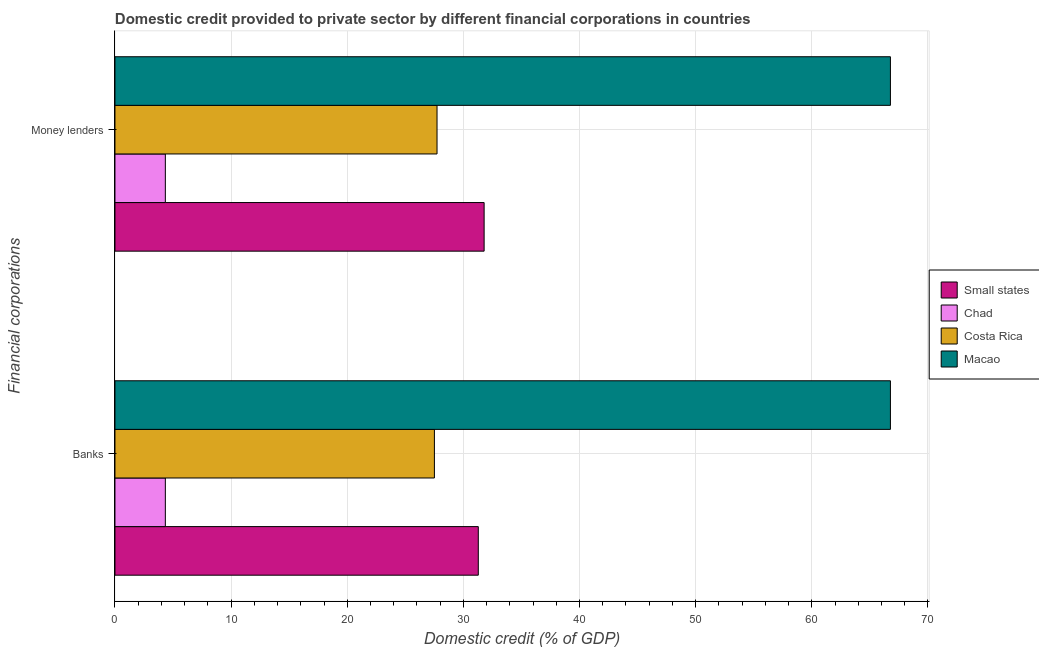How many different coloured bars are there?
Keep it short and to the point. 4. How many groups of bars are there?
Keep it short and to the point. 2. Are the number of bars on each tick of the Y-axis equal?
Ensure brevity in your answer.  Yes. What is the label of the 1st group of bars from the top?
Your response must be concise. Money lenders. What is the domestic credit provided by banks in Small states?
Your answer should be very brief. 31.28. Across all countries, what is the maximum domestic credit provided by money lenders?
Ensure brevity in your answer.  66.77. Across all countries, what is the minimum domestic credit provided by money lenders?
Your response must be concise. 4.34. In which country was the domestic credit provided by banks maximum?
Your response must be concise. Macao. In which country was the domestic credit provided by money lenders minimum?
Make the answer very short. Chad. What is the total domestic credit provided by banks in the graph?
Provide a succinct answer. 129.9. What is the difference between the domestic credit provided by money lenders in Chad and that in Costa Rica?
Offer a very short reply. -23.39. What is the difference between the domestic credit provided by banks in Costa Rica and the domestic credit provided by money lenders in Small states?
Give a very brief answer. -4.28. What is the average domestic credit provided by banks per country?
Provide a succinct answer. 32.48. What is the difference between the domestic credit provided by money lenders and domestic credit provided by banks in Small states?
Provide a short and direct response. 0.5. What is the ratio of the domestic credit provided by money lenders in Macao to that in Small states?
Give a very brief answer. 2.1. In how many countries, is the domestic credit provided by banks greater than the average domestic credit provided by banks taken over all countries?
Offer a very short reply. 1. What does the 4th bar from the top in Banks represents?
Offer a terse response. Small states. What does the 2nd bar from the bottom in Money lenders represents?
Offer a very short reply. Chad. How many countries are there in the graph?
Ensure brevity in your answer.  4. What is the difference between two consecutive major ticks on the X-axis?
Provide a succinct answer. 10. Does the graph contain any zero values?
Provide a succinct answer. No. Does the graph contain grids?
Make the answer very short. Yes. What is the title of the graph?
Your answer should be compact. Domestic credit provided to private sector by different financial corporations in countries. Does "Marshall Islands" appear as one of the legend labels in the graph?
Provide a succinct answer. No. What is the label or title of the X-axis?
Keep it short and to the point. Domestic credit (% of GDP). What is the label or title of the Y-axis?
Ensure brevity in your answer.  Financial corporations. What is the Domestic credit (% of GDP) in Small states in Banks?
Give a very brief answer. 31.28. What is the Domestic credit (% of GDP) in Chad in Banks?
Offer a terse response. 4.34. What is the Domestic credit (% of GDP) in Costa Rica in Banks?
Your answer should be very brief. 27.51. What is the Domestic credit (% of GDP) in Macao in Banks?
Ensure brevity in your answer.  66.77. What is the Domestic credit (% of GDP) of Small states in Money lenders?
Your answer should be very brief. 31.79. What is the Domestic credit (% of GDP) in Chad in Money lenders?
Keep it short and to the point. 4.34. What is the Domestic credit (% of GDP) of Costa Rica in Money lenders?
Provide a short and direct response. 27.73. What is the Domestic credit (% of GDP) of Macao in Money lenders?
Give a very brief answer. 66.77. Across all Financial corporations, what is the maximum Domestic credit (% of GDP) in Small states?
Offer a very short reply. 31.79. Across all Financial corporations, what is the maximum Domestic credit (% of GDP) of Chad?
Your answer should be very brief. 4.34. Across all Financial corporations, what is the maximum Domestic credit (% of GDP) of Costa Rica?
Ensure brevity in your answer.  27.73. Across all Financial corporations, what is the maximum Domestic credit (% of GDP) of Macao?
Keep it short and to the point. 66.77. Across all Financial corporations, what is the minimum Domestic credit (% of GDP) in Small states?
Your response must be concise. 31.28. Across all Financial corporations, what is the minimum Domestic credit (% of GDP) in Chad?
Provide a short and direct response. 4.34. Across all Financial corporations, what is the minimum Domestic credit (% of GDP) in Costa Rica?
Offer a very short reply. 27.51. Across all Financial corporations, what is the minimum Domestic credit (% of GDP) of Macao?
Your answer should be compact. 66.77. What is the total Domestic credit (% of GDP) of Small states in the graph?
Provide a short and direct response. 63.07. What is the total Domestic credit (% of GDP) in Chad in the graph?
Your answer should be very brief. 8.68. What is the total Domestic credit (% of GDP) of Costa Rica in the graph?
Provide a short and direct response. 55.24. What is the total Domestic credit (% of GDP) of Macao in the graph?
Keep it short and to the point. 133.54. What is the difference between the Domestic credit (% of GDP) in Small states in Banks and that in Money lenders?
Your answer should be very brief. -0.5. What is the difference between the Domestic credit (% of GDP) of Chad in Banks and that in Money lenders?
Provide a short and direct response. 0. What is the difference between the Domestic credit (% of GDP) in Costa Rica in Banks and that in Money lenders?
Make the answer very short. -0.23. What is the difference between the Domestic credit (% of GDP) in Small states in Banks and the Domestic credit (% of GDP) in Chad in Money lenders?
Offer a terse response. 26.95. What is the difference between the Domestic credit (% of GDP) in Small states in Banks and the Domestic credit (% of GDP) in Costa Rica in Money lenders?
Your answer should be compact. 3.55. What is the difference between the Domestic credit (% of GDP) of Small states in Banks and the Domestic credit (% of GDP) of Macao in Money lenders?
Provide a short and direct response. -35.49. What is the difference between the Domestic credit (% of GDP) of Chad in Banks and the Domestic credit (% of GDP) of Costa Rica in Money lenders?
Your answer should be very brief. -23.39. What is the difference between the Domestic credit (% of GDP) of Chad in Banks and the Domestic credit (% of GDP) of Macao in Money lenders?
Keep it short and to the point. -62.43. What is the difference between the Domestic credit (% of GDP) of Costa Rica in Banks and the Domestic credit (% of GDP) of Macao in Money lenders?
Provide a succinct answer. -39.27. What is the average Domestic credit (% of GDP) in Small states per Financial corporations?
Make the answer very short. 31.54. What is the average Domestic credit (% of GDP) of Chad per Financial corporations?
Offer a terse response. 4.34. What is the average Domestic credit (% of GDP) of Costa Rica per Financial corporations?
Provide a short and direct response. 27.62. What is the average Domestic credit (% of GDP) in Macao per Financial corporations?
Give a very brief answer. 66.77. What is the difference between the Domestic credit (% of GDP) of Small states and Domestic credit (% of GDP) of Chad in Banks?
Make the answer very short. 26.95. What is the difference between the Domestic credit (% of GDP) in Small states and Domestic credit (% of GDP) in Costa Rica in Banks?
Keep it short and to the point. 3.78. What is the difference between the Domestic credit (% of GDP) of Small states and Domestic credit (% of GDP) of Macao in Banks?
Give a very brief answer. -35.49. What is the difference between the Domestic credit (% of GDP) in Chad and Domestic credit (% of GDP) in Costa Rica in Banks?
Give a very brief answer. -23.17. What is the difference between the Domestic credit (% of GDP) of Chad and Domestic credit (% of GDP) of Macao in Banks?
Make the answer very short. -62.43. What is the difference between the Domestic credit (% of GDP) of Costa Rica and Domestic credit (% of GDP) of Macao in Banks?
Give a very brief answer. -39.27. What is the difference between the Domestic credit (% of GDP) in Small states and Domestic credit (% of GDP) in Chad in Money lenders?
Your answer should be very brief. 27.45. What is the difference between the Domestic credit (% of GDP) of Small states and Domestic credit (% of GDP) of Costa Rica in Money lenders?
Your answer should be very brief. 4.06. What is the difference between the Domestic credit (% of GDP) of Small states and Domestic credit (% of GDP) of Macao in Money lenders?
Offer a very short reply. -34.98. What is the difference between the Domestic credit (% of GDP) of Chad and Domestic credit (% of GDP) of Costa Rica in Money lenders?
Provide a succinct answer. -23.39. What is the difference between the Domestic credit (% of GDP) in Chad and Domestic credit (% of GDP) in Macao in Money lenders?
Your answer should be compact. -62.43. What is the difference between the Domestic credit (% of GDP) in Costa Rica and Domestic credit (% of GDP) in Macao in Money lenders?
Make the answer very short. -39.04. What is the ratio of the Domestic credit (% of GDP) in Small states in Banks to that in Money lenders?
Offer a terse response. 0.98. What is the ratio of the Domestic credit (% of GDP) in Chad in Banks to that in Money lenders?
Give a very brief answer. 1. What is the ratio of the Domestic credit (% of GDP) in Macao in Banks to that in Money lenders?
Offer a very short reply. 1. What is the difference between the highest and the second highest Domestic credit (% of GDP) in Small states?
Provide a succinct answer. 0.5. What is the difference between the highest and the second highest Domestic credit (% of GDP) of Chad?
Ensure brevity in your answer.  0. What is the difference between the highest and the second highest Domestic credit (% of GDP) of Costa Rica?
Your answer should be very brief. 0.23. What is the difference between the highest and the lowest Domestic credit (% of GDP) of Small states?
Your answer should be very brief. 0.5. What is the difference between the highest and the lowest Domestic credit (% of GDP) in Chad?
Offer a terse response. 0. What is the difference between the highest and the lowest Domestic credit (% of GDP) of Costa Rica?
Give a very brief answer. 0.23. What is the difference between the highest and the lowest Domestic credit (% of GDP) of Macao?
Offer a terse response. 0. 